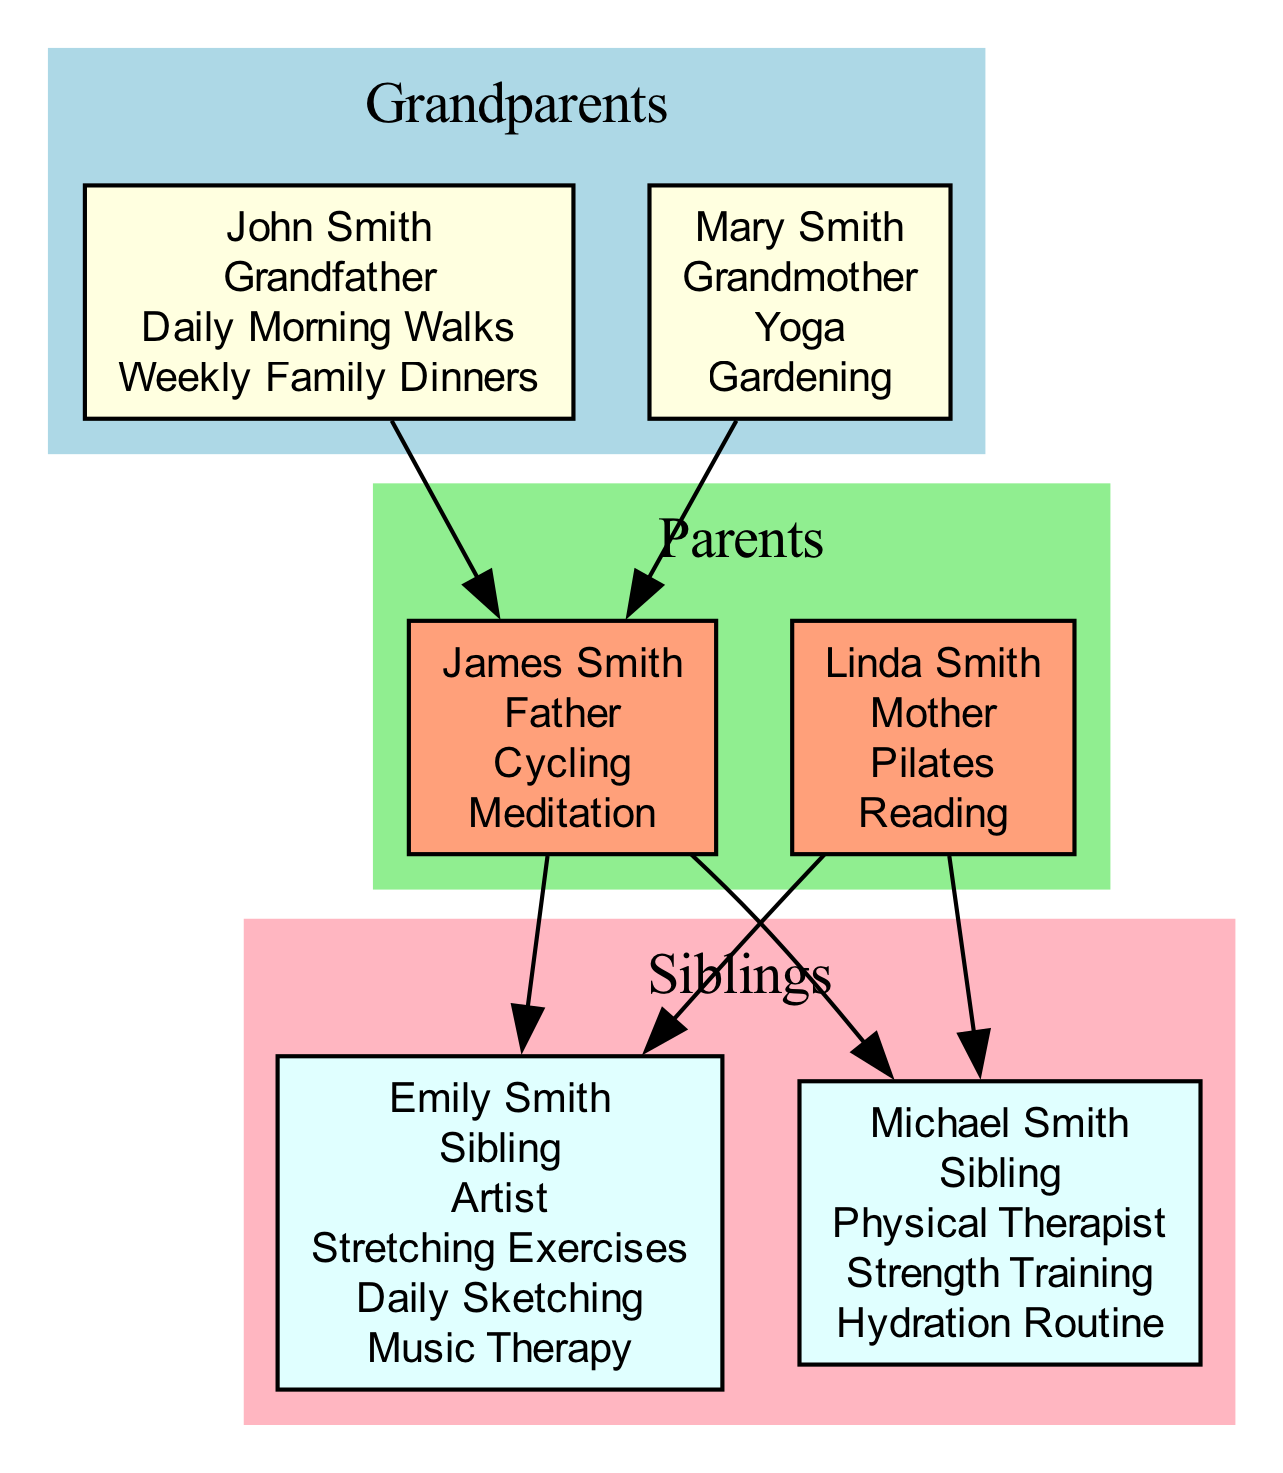What activities does John Smith practice for health? By examining the diagram, we see John Smith listed with two practices: "Daily Morning Walks" for physical health and "Weekly Family Dinners" for mental well-being.
Answer: Daily Morning Walks, Weekly Family Dinners How many members are in the Smith family? Counting all the nodes representing family members in the diagram, including grandparents, parents, and siblings, we find a total of six members.
Answer: 6 What is the relation of Michael Smith to John Smith? The diagram shows that Michael Smith is a sibling, and Michael's father is James Smith, who is the son of John Smith. Thus, Michael is John Smith's grandson.
Answer: Grandson Which member practices Yoga? Looking at the diagram, we can find that Mary Smith, the grandmother, is associated with the practice of Yoga for mental and physical health.
Answer: Mary Smith What is the benefit of Emily Smith's daily sketching practice? The diagram states that Emily Smith practices daily sketching, which is for mental well-being. This is indicated directly in her list of practices.
Answer: Mental well-being How does Michael Smith maintain overall well-being? The diagram highlights that Michael Smith follows a "Hydration Routine," which is specifically noted as beneficial for overall well-being.
Answer: Hydration Routine What is the common practice for physical health among family members? Reviewing the diagram, "Daily Morning Walks" by John Smith and "Cycling" by James Smith are both listed, indicating these are common practices for promoting physical health.
Answer: Daily Morning Walks, Cycling Which sibling focuses on injury prevention through stretching? The diagram identifies that Emily Smith focuses on injury prevention by practicing "Stretching Exercises." This detail is clearly outlined in her section.
Answer: Emily Smith How many different practices does the family have for mental well-being? By reviewing the diagram, practices specifically for mental well-being include "Weekly Family Dinners," "Gardening," "Meditation," "Reading," "Daily Sketching," and "Music Therapy," totaling six distinct practices.
Answer: 6 